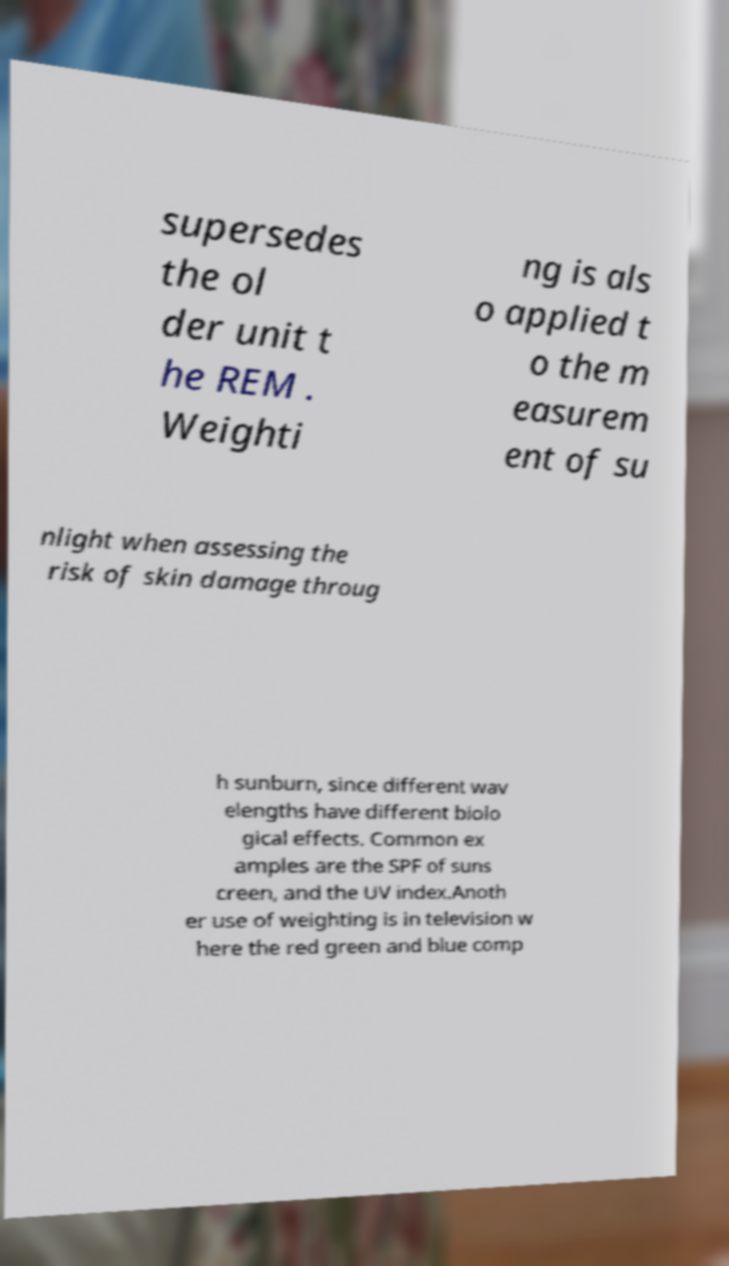Please read and relay the text visible in this image. What does it say? supersedes the ol der unit t he REM . Weighti ng is als o applied t o the m easurem ent of su nlight when assessing the risk of skin damage throug h sunburn, since different wav elengths have different biolo gical effects. Common ex amples are the SPF of suns creen, and the UV index.Anoth er use of weighting is in television w here the red green and blue comp 